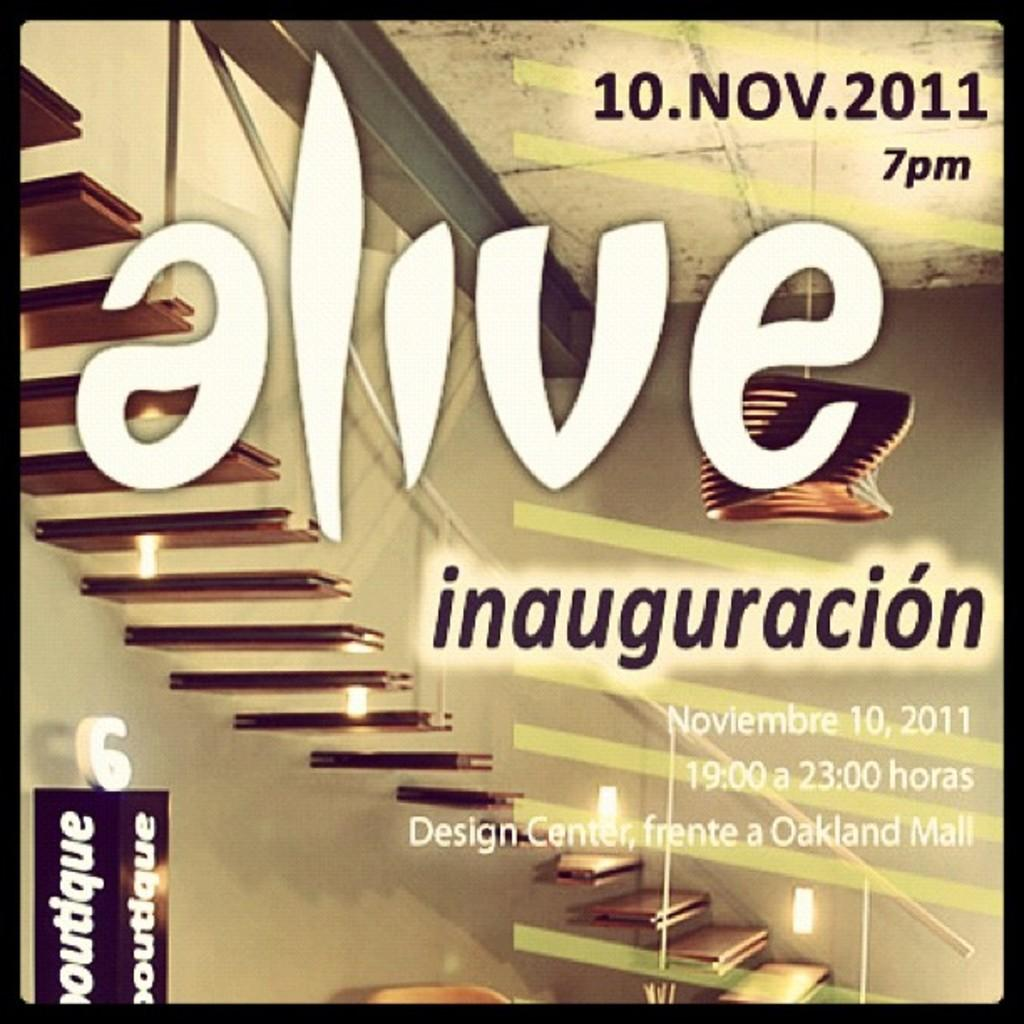What is the main feature of the glass object in the image? There is text and numbers on a glass object in the image. What can be seen through the glass object? A staircase and a railing are visible through the glass object. What is visible in the background of the image? A wall is visible in the background of the image. How many sheep are grazing in the cave in the image? There are no sheep or caves present in the image. 